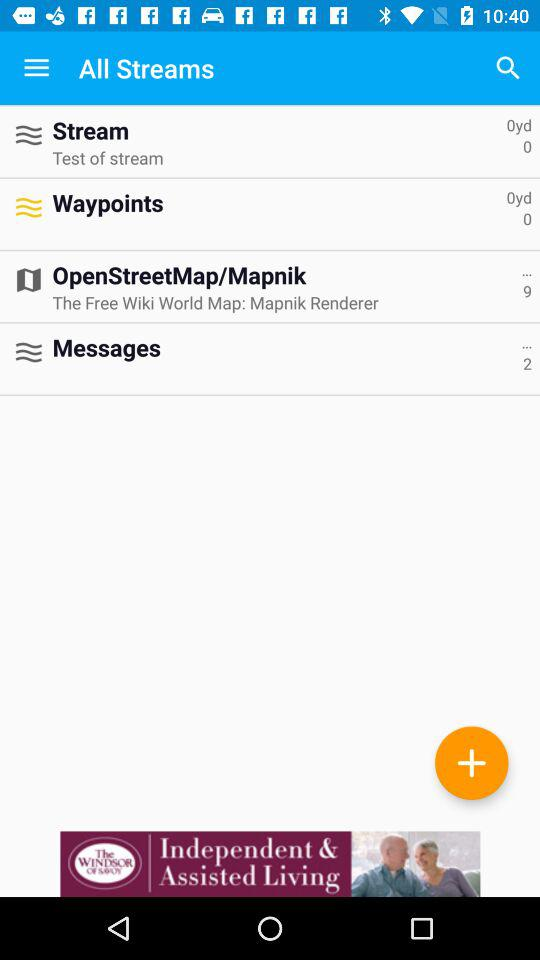How many items are there in "OpenStreetMap/Mapnik"? There are 9 items. 